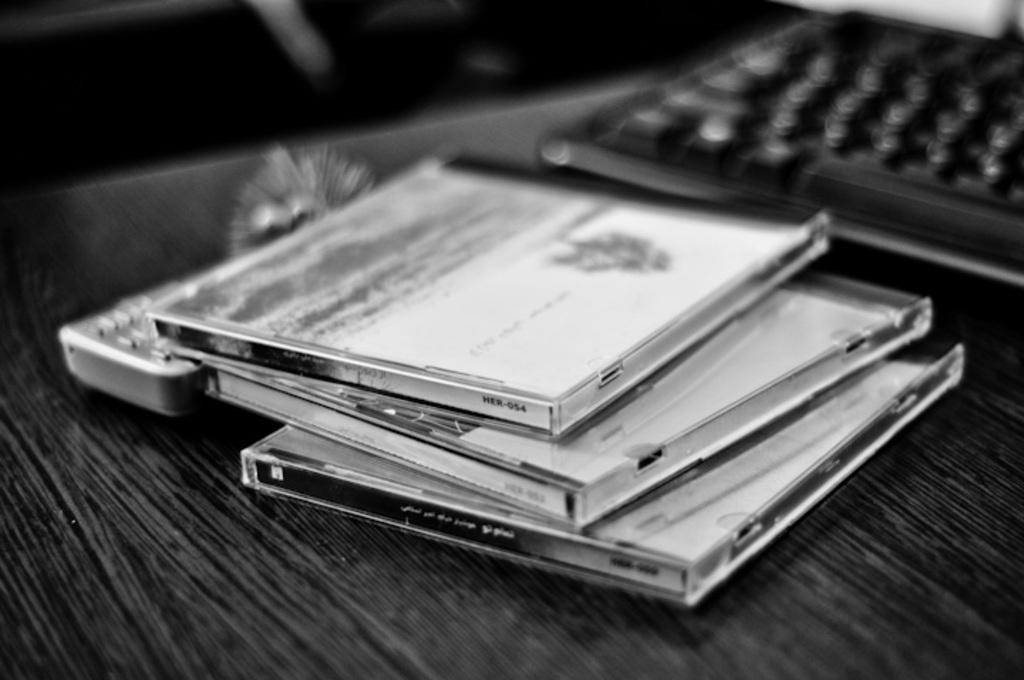Provide a one-sentence caption for the provided image. A qwerty keyboard sitting on a table next to CD's. 